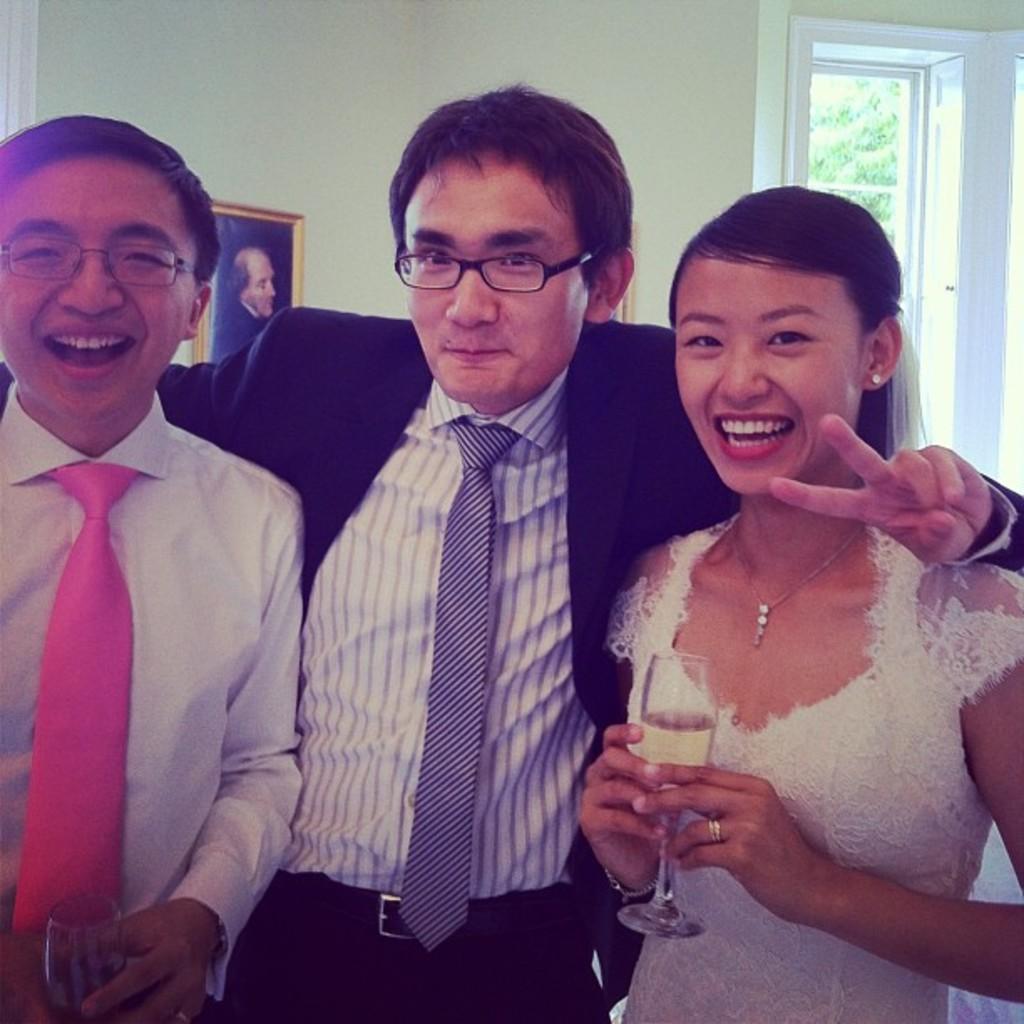In one or two sentences, can you explain what this image depicts? In this image three people are standing in the foreground. The right one is a lady wearing gown. She is holding a wine glass. all of them are smiling. In the background there is wall , window. On the wall there is a photo frame. Through the window we can see trees. 